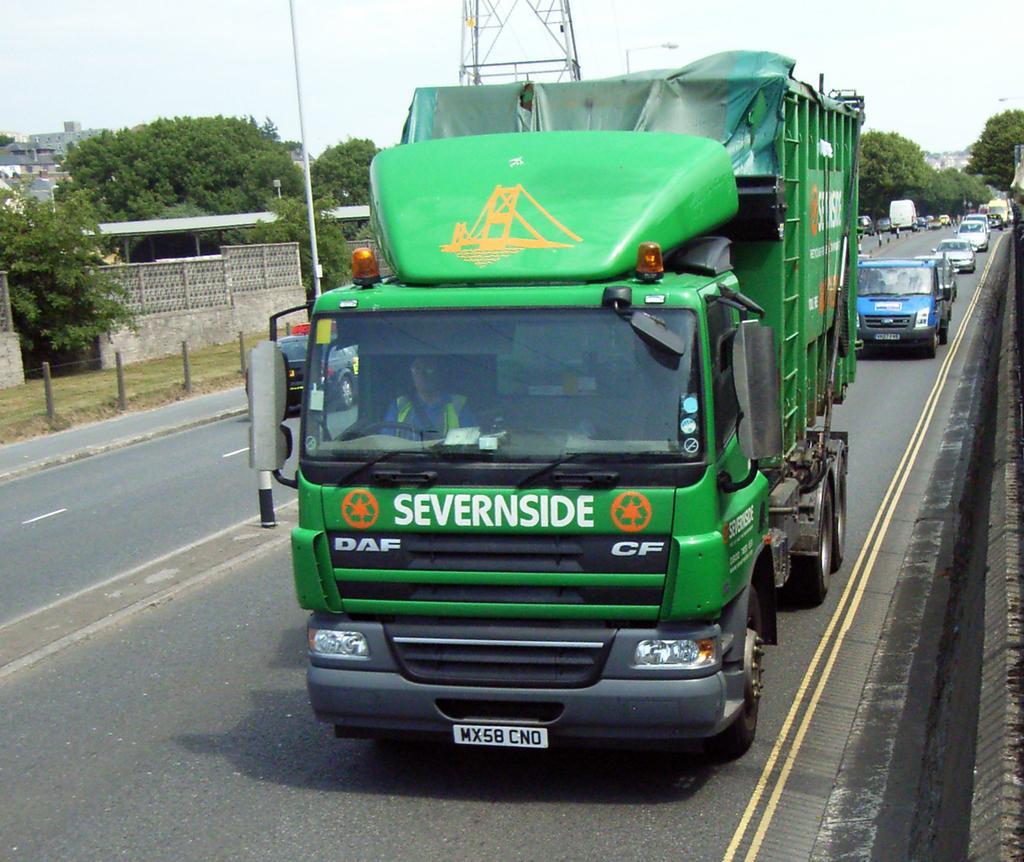Please provide a concise description of this image. In this picture we can see vehicles on the road, fence, grass, trees, buildings, pole, tower and in the background we can see sky. 